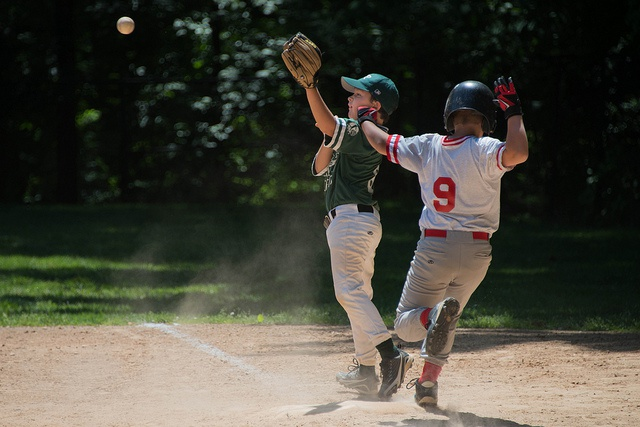Describe the objects in this image and their specific colors. I can see people in black, gray, and darkgray tones, people in black, darkgray, and gray tones, baseball glove in black, maroon, and brown tones, and sports ball in black, gray, tan, and darkgray tones in this image. 